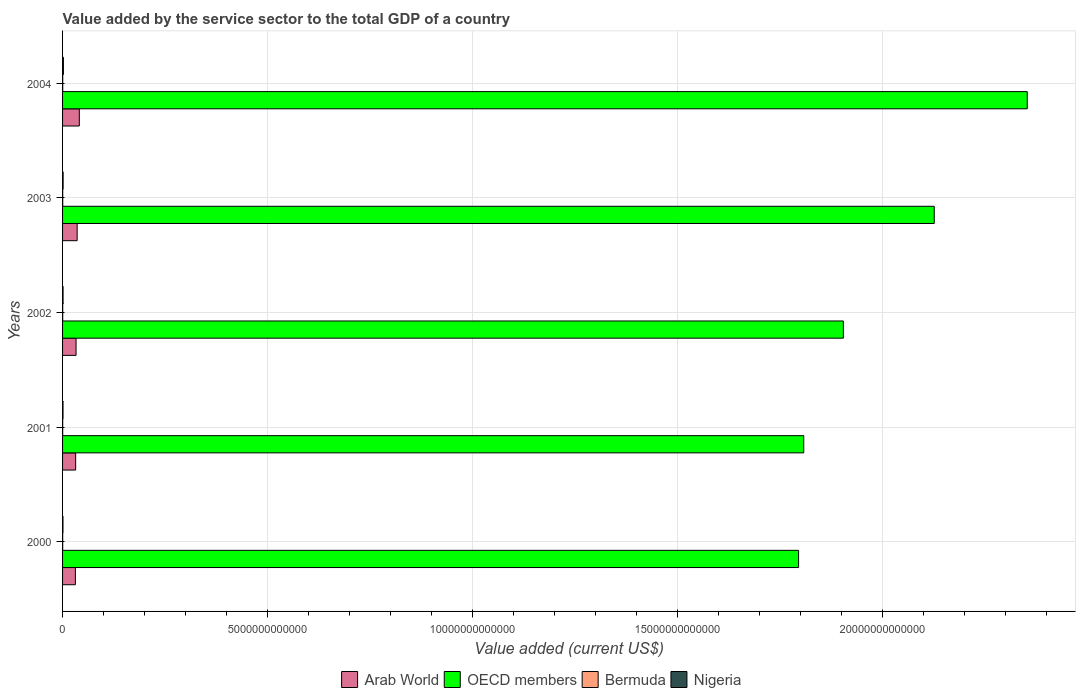How many bars are there on the 2nd tick from the top?
Provide a succinct answer. 4. How many bars are there on the 4th tick from the bottom?
Give a very brief answer. 4. What is the value added by the service sector to the total GDP in Nigeria in 2002?
Your answer should be very brief. 1.20e+1. Across all years, what is the maximum value added by the service sector to the total GDP in Arab World?
Offer a very short reply. 4.08e+11. Across all years, what is the minimum value added by the service sector to the total GDP in OECD members?
Offer a terse response. 1.79e+13. In which year was the value added by the service sector to the total GDP in OECD members maximum?
Offer a very short reply. 2004. What is the total value added by the service sector to the total GDP in OECD members in the graph?
Offer a terse response. 9.98e+13. What is the difference between the value added by the service sector to the total GDP in Bermuda in 2000 and that in 2001?
Ensure brevity in your answer.  -2.03e+08. What is the difference between the value added by the service sector to the total GDP in Bermuda in 2004 and the value added by the service sector to the total GDP in Arab World in 2002?
Ensure brevity in your answer.  -3.25e+11. What is the average value added by the service sector to the total GDP in Nigeria per year?
Your answer should be very brief. 1.33e+1. In the year 2001, what is the difference between the value added by the service sector to the total GDP in Arab World and value added by the service sector to the total GDP in OECD members?
Ensure brevity in your answer.  -1.78e+13. In how many years, is the value added by the service sector to the total GDP in Arab World greater than 10000000000000 US$?
Offer a very short reply. 0. What is the ratio of the value added by the service sector to the total GDP in Arab World in 2002 to that in 2003?
Ensure brevity in your answer.  0.93. What is the difference between the highest and the second highest value added by the service sector to the total GDP in Bermuda?
Your answer should be very brief. 2.45e+08. What is the difference between the highest and the lowest value added by the service sector to the total GDP in Arab World?
Provide a short and direct response. 9.59e+1. In how many years, is the value added by the service sector to the total GDP in Arab World greater than the average value added by the service sector to the total GDP in Arab World taken over all years?
Ensure brevity in your answer.  2. Is the sum of the value added by the service sector to the total GDP in Bermuda in 2000 and 2004 greater than the maximum value added by the service sector to the total GDP in OECD members across all years?
Make the answer very short. No. What does the 2nd bar from the top in 2004 represents?
Make the answer very short. Bermuda. Is it the case that in every year, the sum of the value added by the service sector to the total GDP in Nigeria and value added by the service sector to the total GDP in Arab World is greater than the value added by the service sector to the total GDP in Bermuda?
Offer a very short reply. Yes. Are all the bars in the graph horizontal?
Ensure brevity in your answer.  Yes. What is the difference between two consecutive major ticks on the X-axis?
Your answer should be compact. 5.00e+12. Does the graph contain any zero values?
Offer a very short reply. No. How many legend labels are there?
Keep it short and to the point. 4. What is the title of the graph?
Provide a short and direct response. Value added by the service sector to the total GDP of a country. What is the label or title of the X-axis?
Offer a terse response. Value added (current US$). What is the label or title of the Y-axis?
Your response must be concise. Years. What is the Value added (current US$) in Arab World in 2000?
Your answer should be very brief. 3.13e+11. What is the Value added (current US$) of OECD members in 2000?
Provide a short and direct response. 1.79e+13. What is the Value added (current US$) of Bermuda in 2000?
Keep it short and to the point. 2.89e+09. What is the Value added (current US$) of Nigeria in 2000?
Keep it short and to the point. 9.80e+09. What is the Value added (current US$) in Arab World in 2001?
Offer a very short reply. 3.19e+11. What is the Value added (current US$) of OECD members in 2001?
Provide a short and direct response. 1.81e+13. What is the Value added (current US$) in Bermuda in 2001?
Your response must be concise. 3.09e+09. What is the Value added (current US$) in Nigeria in 2001?
Your answer should be compact. 1.08e+1. What is the Value added (current US$) of Arab World in 2002?
Your response must be concise. 3.29e+11. What is the Value added (current US$) of OECD members in 2002?
Make the answer very short. 1.90e+13. What is the Value added (current US$) of Bermuda in 2002?
Provide a short and direct response. 3.34e+09. What is the Value added (current US$) of Nigeria in 2002?
Ensure brevity in your answer.  1.20e+1. What is the Value added (current US$) in Arab World in 2003?
Offer a very short reply. 3.56e+11. What is the Value added (current US$) of OECD members in 2003?
Provide a succinct answer. 2.13e+13. What is the Value added (current US$) of Bermuda in 2003?
Keep it short and to the point. 3.55e+09. What is the Value added (current US$) in Nigeria in 2003?
Keep it short and to the point. 1.35e+1. What is the Value added (current US$) in Arab World in 2004?
Your answer should be compact. 4.08e+11. What is the Value added (current US$) of OECD members in 2004?
Provide a short and direct response. 2.35e+13. What is the Value added (current US$) of Bermuda in 2004?
Provide a short and direct response. 3.80e+09. What is the Value added (current US$) in Nigeria in 2004?
Your answer should be compact. 2.04e+1. Across all years, what is the maximum Value added (current US$) in Arab World?
Provide a succinct answer. 4.08e+11. Across all years, what is the maximum Value added (current US$) of OECD members?
Keep it short and to the point. 2.35e+13. Across all years, what is the maximum Value added (current US$) in Bermuda?
Give a very brief answer. 3.80e+09. Across all years, what is the maximum Value added (current US$) in Nigeria?
Your answer should be very brief. 2.04e+1. Across all years, what is the minimum Value added (current US$) in Arab World?
Offer a terse response. 3.13e+11. Across all years, what is the minimum Value added (current US$) in OECD members?
Your answer should be compact. 1.79e+13. Across all years, what is the minimum Value added (current US$) in Bermuda?
Give a very brief answer. 2.89e+09. Across all years, what is the minimum Value added (current US$) of Nigeria?
Ensure brevity in your answer.  9.80e+09. What is the total Value added (current US$) in Arab World in the graph?
Your answer should be very brief. 1.72e+12. What is the total Value added (current US$) in OECD members in the graph?
Your answer should be compact. 9.98e+13. What is the total Value added (current US$) in Bermuda in the graph?
Offer a very short reply. 1.67e+1. What is the total Value added (current US$) of Nigeria in the graph?
Make the answer very short. 6.64e+1. What is the difference between the Value added (current US$) of Arab World in 2000 and that in 2001?
Give a very brief answer. -6.45e+09. What is the difference between the Value added (current US$) in OECD members in 2000 and that in 2001?
Your answer should be compact. -1.26e+11. What is the difference between the Value added (current US$) in Bermuda in 2000 and that in 2001?
Offer a very short reply. -2.03e+08. What is the difference between the Value added (current US$) in Nigeria in 2000 and that in 2001?
Offer a terse response. -9.74e+08. What is the difference between the Value added (current US$) of Arab World in 2000 and that in 2002?
Offer a terse response. -1.66e+1. What is the difference between the Value added (current US$) in OECD members in 2000 and that in 2002?
Your answer should be compact. -1.09e+12. What is the difference between the Value added (current US$) in Bermuda in 2000 and that in 2002?
Provide a succinct answer. -4.53e+08. What is the difference between the Value added (current US$) in Nigeria in 2000 and that in 2002?
Your answer should be compact. -2.19e+09. What is the difference between the Value added (current US$) in Arab World in 2000 and that in 2003?
Your response must be concise. -4.30e+1. What is the difference between the Value added (current US$) of OECD members in 2000 and that in 2003?
Offer a terse response. -3.31e+12. What is the difference between the Value added (current US$) of Bermuda in 2000 and that in 2003?
Your response must be concise. -6.67e+08. What is the difference between the Value added (current US$) of Nigeria in 2000 and that in 2003?
Ensure brevity in your answer.  -3.69e+09. What is the difference between the Value added (current US$) in Arab World in 2000 and that in 2004?
Offer a very short reply. -9.59e+1. What is the difference between the Value added (current US$) of OECD members in 2000 and that in 2004?
Your answer should be compact. -5.58e+12. What is the difference between the Value added (current US$) of Bermuda in 2000 and that in 2004?
Offer a very short reply. -9.12e+08. What is the difference between the Value added (current US$) of Nigeria in 2000 and that in 2004?
Provide a short and direct response. -1.05e+1. What is the difference between the Value added (current US$) in Arab World in 2001 and that in 2002?
Your answer should be very brief. -1.02e+1. What is the difference between the Value added (current US$) in OECD members in 2001 and that in 2002?
Your response must be concise. -9.65e+11. What is the difference between the Value added (current US$) of Bermuda in 2001 and that in 2002?
Offer a terse response. -2.49e+08. What is the difference between the Value added (current US$) in Nigeria in 2001 and that in 2002?
Give a very brief answer. -1.21e+09. What is the difference between the Value added (current US$) in Arab World in 2001 and that in 2003?
Your response must be concise. -3.66e+1. What is the difference between the Value added (current US$) in OECD members in 2001 and that in 2003?
Offer a very short reply. -3.18e+12. What is the difference between the Value added (current US$) in Bermuda in 2001 and that in 2003?
Ensure brevity in your answer.  -4.64e+08. What is the difference between the Value added (current US$) in Nigeria in 2001 and that in 2003?
Ensure brevity in your answer.  -2.71e+09. What is the difference between the Value added (current US$) of Arab World in 2001 and that in 2004?
Your response must be concise. -8.95e+1. What is the difference between the Value added (current US$) in OECD members in 2001 and that in 2004?
Offer a very short reply. -5.45e+12. What is the difference between the Value added (current US$) of Bermuda in 2001 and that in 2004?
Give a very brief answer. -7.08e+08. What is the difference between the Value added (current US$) in Nigeria in 2001 and that in 2004?
Provide a succinct answer. -9.57e+09. What is the difference between the Value added (current US$) of Arab World in 2002 and that in 2003?
Your response must be concise. -2.64e+1. What is the difference between the Value added (current US$) in OECD members in 2002 and that in 2003?
Provide a succinct answer. -2.22e+12. What is the difference between the Value added (current US$) in Bermuda in 2002 and that in 2003?
Your answer should be compact. -2.14e+08. What is the difference between the Value added (current US$) in Nigeria in 2002 and that in 2003?
Provide a succinct answer. -1.50e+09. What is the difference between the Value added (current US$) in Arab World in 2002 and that in 2004?
Provide a succinct answer. -7.93e+1. What is the difference between the Value added (current US$) in OECD members in 2002 and that in 2004?
Keep it short and to the point. -4.48e+12. What is the difference between the Value added (current US$) in Bermuda in 2002 and that in 2004?
Your answer should be very brief. -4.59e+08. What is the difference between the Value added (current US$) in Nigeria in 2002 and that in 2004?
Provide a short and direct response. -8.36e+09. What is the difference between the Value added (current US$) in Arab World in 2003 and that in 2004?
Offer a terse response. -5.29e+1. What is the difference between the Value added (current US$) in OECD members in 2003 and that in 2004?
Provide a succinct answer. -2.27e+12. What is the difference between the Value added (current US$) of Bermuda in 2003 and that in 2004?
Your response must be concise. -2.45e+08. What is the difference between the Value added (current US$) in Nigeria in 2003 and that in 2004?
Make the answer very short. -6.86e+09. What is the difference between the Value added (current US$) in Arab World in 2000 and the Value added (current US$) in OECD members in 2001?
Your response must be concise. -1.78e+13. What is the difference between the Value added (current US$) in Arab World in 2000 and the Value added (current US$) in Bermuda in 2001?
Offer a terse response. 3.09e+11. What is the difference between the Value added (current US$) of Arab World in 2000 and the Value added (current US$) of Nigeria in 2001?
Give a very brief answer. 3.02e+11. What is the difference between the Value added (current US$) of OECD members in 2000 and the Value added (current US$) of Bermuda in 2001?
Provide a short and direct response. 1.79e+13. What is the difference between the Value added (current US$) of OECD members in 2000 and the Value added (current US$) of Nigeria in 2001?
Provide a succinct answer. 1.79e+13. What is the difference between the Value added (current US$) of Bermuda in 2000 and the Value added (current US$) of Nigeria in 2001?
Give a very brief answer. -7.89e+09. What is the difference between the Value added (current US$) of Arab World in 2000 and the Value added (current US$) of OECD members in 2002?
Your answer should be compact. -1.87e+13. What is the difference between the Value added (current US$) in Arab World in 2000 and the Value added (current US$) in Bermuda in 2002?
Your response must be concise. 3.09e+11. What is the difference between the Value added (current US$) of Arab World in 2000 and the Value added (current US$) of Nigeria in 2002?
Give a very brief answer. 3.01e+11. What is the difference between the Value added (current US$) of OECD members in 2000 and the Value added (current US$) of Bermuda in 2002?
Your answer should be compact. 1.79e+13. What is the difference between the Value added (current US$) in OECD members in 2000 and the Value added (current US$) in Nigeria in 2002?
Ensure brevity in your answer.  1.79e+13. What is the difference between the Value added (current US$) in Bermuda in 2000 and the Value added (current US$) in Nigeria in 2002?
Your answer should be very brief. -9.10e+09. What is the difference between the Value added (current US$) of Arab World in 2000 and the Value added (current US$) of OECD members in 2003?
Your answer should be compact. -2.09e+13. What is the difference between the Value added (current US$) in Arab World in 2000 and the Value added (current US$) in Bermuda in 2003?
Give a very brief answer. 3.09e+11. What is the difference between the Value added (current US$) in Arab World in 2000 and the Value added (current US$) in Nigeria in 2003?
Offer a terse response. 2.99e+11. What is the difference between the Value added (current US$) in OECD members in 2000 and the Value added (current US$) in Bermuda in 2003?
Ensure brevity in your answer.  1.79e+13. What is the difference between the Value added (current US$) in OECD members in 2000 and the Value added (current US$) in Nigeria in 2003?
Keep it short and to the point. 1.79e+13. What is the difference between the Value added (current US$) of Bermuda in 2000 and the Value added (current US$) of Nigeria in 2003?
Your answer should be very brief. -1.06e+1. What is the difference between the Value added (current US$) of Arab World in 2000 and the Value added (current US$) of OECD members in 2004?
Offer a very short reply. -2.32e+13. What is the difference between the Value added (current US$) of Arab World in 2000 and the Value added (current US$) of Bermuda in 2004?
Keep it short and to the point. 3.09e+11. What is the difference between the Value added (current US$) of Arab World in 2000 and the Value added (current US$) of Nigeria in 2004?
Your answer should be compact. 2.92e+11. What is the difference between the Value added (current US$) in OECD members in 2000 and the Value added (current US$) in Bermuda in 2004?
Give a very brief answer. 1.79e+13. What is the difference between the Value added (current US$) of OECD members in 2000 and the Value added (current US$) of Nigeria in 2004?
Provide a succinct answer. 1.79e+13. What is the difference between the Value added (current US$) of Bermuda in 2000 and the Value added (current US$) of Nigeria in 2004?
Make the answer very short. -1.75e+1. What is the difference between the Value added (current US$) of Arab World in 2001 and the Value added (current US$) of OECD members in 2002?
Your answer should be very brief. -1.87e+13. What is the difference between the Value added (current US$) in Arab World in 2001 and the Value added (current US$) in Bermuda in 2002?
Offer a terse response. 3.16e+11. What is the difference between the Value added (current US$) of Arab World in 2001 and the Value added (current US$) of Nigeria in 2002?
Keep it short and to the point. 3.07e+11. What is the difference between the Value added (current US$) in OECD members in 2001 and the Value added (current US$) in Bermuda in 2002?
Provide a short and direct response. 1.81e+13. What is the difference between the Value added (current US$) of OECD members in 2001 and the Value added (current US$) of Nigeria in 2002?
Make the answer very short. 1.81e+13. What is the difference between the Value added (current US$) in Bermuda in 2001 and the Value added (current US$) in Nigeria in 2002?
Provide a succinct answer. -8.90e+09. What is the difference between the Value added (current US$) in Arab World in 2001 and the Value added (current US$) in OECD members in 2003?
Offer a very short reply. -2.09e+13. What is the difference between the Value added (current US$) in Arab World in 2001 and the Value added (current US$) in Bermuda in 2003?
Provide a short and direct response. 3.15e+11. What is the difference between the Value added (current US$) in Arab World in 2001 and the Value added (current US$) in Nigeria in 2003?
Offer a terse response. 3.05e+11. What is the difference between the Value added (current US$) in OECD members in 2001 and the Value added (current US$) in Bermuda in 2003?
Keep it short and to the point. 1.81e+13. What is the difference between the Value added (current US$) of OECD members in 2001 and the Value added (current US$) of Nigeria in 2003?
Your answer should be very brief. 1.81e+13. What is the difference between the Value added (current US$) in Bermuda in 2001 and the Value added (current US$) in Nigeria in 2003?
Keep it short and to the point. -1.04e+1. What is the difference between the Value added (current US$) in Arab World in 2001 and the Value added (current US$) in OECD members in 2004?
Your answer should be compact. -2.32e+13. What is the difference between the Value added (current US$) in Arab World in 2001 and the Value added (current US$) in Bermuda in 2004?
Your answer should be very brief. 3.15e+11. What is the difference between the Value added (current US$) in Arab World in 2001 and the Value added (current US$) in Nigeria in 2004?
Provide a short and direct response. 2.99e+11. What is the difference between the Value added (current US$) of OECD members in 2001 and the Value added (current US$) of Bermuda in 2004?
Make the answer very short. 1.81e+13. What is the difference between the Value added (current US$) of OECD members in 2001 and the Value added (current US$) of Nigeria in 2004?
Provide a short and direct response. 1.80e+13. What is the difference between the Value added (current US$) of Bermuda in 2001 and the Value added (current US$) of Nigeria in 2004?
Ensure brevity in your answer.  -1.73e+1. What is the difference between the Value added (current US$) of Arab World in 2002 and the Value added (current US$) of OECD members in 2003?
Ensure brevity in your answer.  -2.09e+13. What is the difference between the Value added (current US$) of Arab World in 2002 and the Value added (current US$) of Bermuda in 2003?
Give a very brief answer. 3.26e+11. What is the difference between the Value added (current US$) in Arab World in 2002 and the Value added (current US$) in Nigeria in 2003?
Your answer should be very brief. 3.16e+11. What is the difference between the Value added (current US$) of OECD members in 2002 and the Value added (current US$) of Bermuda in 2003?
Your answer should be compact. 1.90e+13. What is the difference between the Value added (current US$) of OECD members in 2002 and the Value added (current US$) of Nigeria in 2003?
Keep it short and to the point. 1.90e+13. What is the difference between the Value added (current US$) of Bermuda in 2002 and the Value added (current US$) of Nigeria in 2003?
Make the answer very short. -1.02e+1. What is the difference between the Value added (current US$) in Arab World in 2002 and the Value added (current US$) in OECD members in 2004?
Provide a succinct answer. -2.32e+13. What is the difference between the Value added (current US$) in Arab World in 2002 and the Value added (current US$) in Bermuda in 2004?
Offer a very short reply. 3.25e+11. What is the difference between the Value added (current US$) in Arab World in 2002 and the Value added (current US$) in Nigeria in 2004?
Provide a succinct answer. 3.09e+11. What is the difference between the Value added (current US$) of OECD members in 2002 and the Value added (current US$) of Bermuda in 2004?
Provide a short and direct response. 1.90e+13. What is the difference between the Value added (current US$) of OECD members in 2002 and the Value added (current US$) of Nigeria in 2004?
Ensure brevity in your answer.  1.90e+13. What is the difference between the Value added (current US$) in Bermuda in 2002 and the Value added (current US$) in Nigeria in 2004?
Provide a short and direct response. -1.70e+1. What is the difference between the Value added (current US$) of Arab World in 2003 and the Value added (current US$) of OECD members in 2004?
Your response must be concise. -2.32e+13. What is the difference between the Value added (current US$) of Arab World in 2003 and the Value added (current US$) of Bermuda in 2004?
Your answer should be compact. 3.52e+11. What is the difference between the Value added (current US$) of Arab World in 2003 and the Value added (current US$) of Nigeria in 2004?
Make the answer very short. 3.35e+11. What is the difference between the Value added (current US$) in OECD members in 2003 and the Value added (current US$) in Bermuda in 2004?
Your response must be concise. 2.12e+13. What is the difference between the Value added (current US$) of OECD members in 2003 and the Value added (current US$) of Nigeria in 2004?
Ensure brevity in your answer.  2.12e+13. What is the difference between the Value added (current US$) of Bermuda in 2003 and the Value added (current US$) of Nigeria in 2004?
Make the answer very short. -1.68e+1. What is the average Value added (current US$) of Arab World per year?
Your response must be concise. 3.45e+11. What is the average Value added (current US$) in OECD members per year?
Your answer should be very brief. 2.00e+13. What is the average Value added (current US$) in Bermuda per year?
Provide a short and direct response. 3.33e+09. What is the average Value added (current US$) of Nigeria per year?
Make the answer very short. 1.33e+1. In the year 2000, what is the difference between the Value added (current US$) in Arab World and Value added (current US$) in OECD members?
Your answer should be very brief. -1.76e+13. In the year 2000, what is the difference between the Value added (current US$) in Arab World and Value added (current US$) in Bermuda?
Offer a very short reply. 3.10e+11. In the year 2000, what is the difference between the Value added (current US$) in Arab World and Value added (current US$) in Nigeria?
Keep it short and to the point. 3.03e+11. In the year 2000, what is the difference between the Value added (current US$) in OECD members and Value added (current US$) in Bermuda?
Provide a short and direct response. 1.79e+13. In the year 2000, what is the difference between the Value added (current US$) of OECD members and Value added (current US$) of Nigeria?
Provide a succinct answer. 1.79e+13. In the year 2000, what is the difference between the Value added (current US$) of Bermuda and Value added (current US$) of Nigeria?
Your answer should be compact. -6.92e+09. In the year 2001, what is the difference between the Value added (current US$) in Arab World and Value added (current US$) in OECD members?
Your response must be concise. -1.78e+13. In the year 2001, what is the difference between the Value added (current US$) of Arab World and Value added (current US$) of Bermuda?
Ensure brevity in your answer.  3.16e+11. In the year 2001, what is the difference between the Value added (current US$) in Arab World and Value added (current US$) in Nigeria?
Keep it short and to the point. 3.08e+11. In the year 2001, what is the difference between the Value added (current US$) in OECD members and Value added (current US$) in Bermuda?
Your response must be concise. 1.81e+13. In the year 2001, what is the difference between the Value added (current US$) of OECD members and Value added (current US$) of Nigeria?
Your answer should be compact. 1.81e+13. In the year 2001, what is the difference between the Value added (current US$) in Bermuda and Value added (current US$) in Nigeria?
Make the answer very short. -7.69e+09. In the year 2002, what is the difference between the Value added (current US$) in Arab World and Value added (current US$) in OECD members?
Provide a succinct answer. -1.87e+13. In the year 2002, what is the difference between the Value added (current US$) in Arab World and Value added (current US$) in Bermuda?
Keep it short and to the point. 3.26e+11. In the year 2002, what is the difference between the Value added (current US$) in Arab World and Value added (current US$) in Nigeria?
Make the answer very short. 3.17e+11. In the year 2002, what is the difference between the Value added (current US$) of OECD members and Value added (current US$) of Bermuda?
Give a very brief answer. 1.90e+13. In the year 2002, what is the difference between the Value added (current US$) of OECD members and Value added (current US$) of Nigeria?
Your response must be concise. 1.90e+13. In the year 2002, what is the difference between the Value added (current US$) of Bermuda and Value added (current US$) of Nigeria?
Give a very brief answer. -8.65e+09. In the year 2003, what is the difference between the Value added (current US$) of Arab World and Value added (current US$) of OECD members?
Your answer should be compact. -2.09e+13. In the year 2003, what is the difference between the Value added (current US$) of Arab World and Value added (current US$) of Bermuda?
Provide a short and direct response. 3.52e+11. In the year 2003, what is the difference between the Value added (current US$) in Arab World and Value added (current US$) in Nigeria?
Give a very brief answer. 3.42e+11. In the year 2003, what is the difference between the Value added (current US$) of OECD members and Value added (current US$) of Bermuda?
Keep it short and to the point. 2.12e+13. In the year 2003, what is the difference between the Value added (current US$) of OECD members and Value added (current US$) of Nigeria?
Ensure brevity in your answer.  2.12e+13. In the year 2003, what is the difference between the Value added (current US$) in Bermuda and Value added (current US$) in Nigeria?
Provide a succinct answer. -9.94e+09. In the year 2004, what is the difference between the Value added (current US$) of Arab World and Value added (current US$) of OECD members?
Your answer should be compact. -2.31e+13. In the year 2004, what is the difference between the Value added (current US$) in Arab World and Value added (current US$) in Bermuda?
Your response must be concise. 4.05e+11. In the year 2004, what is the difference between the Value added (current US$) of Arab World and Value added (current US$) of Nigeria?
Keep it short and to the point. 3.88e+11. In the year 2004, what is the difference between the Value added (current US$) in OECD members and Value added (current US$) in Bermuda?
Your answer should be very brief. 2.35e+13. In the year 2004, what is the difference between the Value added (current US$) in OECD members and Value added (current US$) in Nigeria?
Your answer should be very brief. 2.35e+13. In the year 2004, what is the difference between the Value added (current US$) of Bermuda and Value added (current US$) of Nigeria?
Your answer should be very brief. -1.66e+1. What is the ratio of the Value added (current US$) of Arab World in 2000 to that in 2001?
Ensure brevity in your answer.  0.98. What is the ratio of the Value added (current US$) in OECD members in 2000 to that in 2001?
Offer a terse response. 0.99. What is the ratio of the Value added (current US$) in Bermuda in 2000 to that in 2001?
Your response must be concise. 0.93. What is the ratio of the Value added (current US$) in Nigeria in 2000 to that in 2001?
Offer a very short reply. 0.91. What is the ratio of the Value added (current US$) in Arab World in 2000 to that in 2002?
Your answer should be compact. 0.95. What is the ratio of the Value added (current US$) in OECD members in 2000 to that in 2002?
Provide a succinct answer. 0.94. What is the ratio of the Value added (current US$) of Bermuda in 2000 to that in 2002?
Offer a very short reply. 0.86. What is the ratio of the Value added (current US$) of Nigeria in 2000 to that in 2002?
Ensure brevity in your answer.  0.82. What is the ratio of the Value added (current US$) of Arab World in 2000 to that in 2003?
Provide a short and direct response. 0.88. What is the ratio of the Value added (current US$) of OECD members in 2000 to that in 2003?
Give a very brief answer. 0.84. What is the ratio of the Value added (current US$) in Bermuda in 2000 to that in 2003?
Ensure brevity in your answer.  0.81. What is the ratio of the Value added (current US$) of Nigeria in 2000 to that in 2003?
Keep it short and to the point. 0.73. What is the ratio of the Value added (current US$) of Arab World in 2000 to that in 2004?
Provide a short and direct response. 0.77. What is the ratio of the Value added (current US$) of OECD members in 2000 to that in 2004?
Offer a very short reply. 0.76. What is the ratio of the Value added (current US$) in Bermuda in 2000 to that in 2004?
Give a very brief answer. 0.76. What is the ratio of the Value added (current US$) in Nigeria in 2000 to that in 2004?
Offer a very short reply. 0.48. What is the ratio of the Value added (current US$) of Arab World in 2001 to that in 2002?
Provide a short and direct response. 0.97. What is the ratio of the Value added (current US$) of OECD members in 2001 to that in 2002?
Your response must be concise. 0.95. What is the ratio of the Value added (current US$) of Bermuda in 2001 to that in 2002?
Offer a very short reply. 0.93. What is the ratio of the Value added (current US$) of Nigeria in 2001 to that in 2002?
Provide a succinct answer. 0.9. What is the ratio of the Value added (current US$) in Arab World in 2001 to that in 2003?
Offer a terse response. 0.9. What is the ratio of the Value added (current US$) in OECD members in 2001 to that in 2003?
Your response must be concise. 0.85. What is the ratio of the Value added (current US$) in Bermuda in 2001 to that in 2003?
Your response must be concise. 0.87. What is the ratio of the Value added (current US$) of Nigeria in 2001 to that in 2003?
Ensure brevity in your answer.  0.8. What is the ratio of the Value added (current US$) of Arab World in 2001 to that in 2004?
Offer a terse response. 0.78. What is the ratio of the Value added (current US$) in OECD members in 2001 to that in 2004?
Offer a very short reply. 0.77. What is the ratio of the Value added (current US$) of Bermuda in 2001 to that in 2004?
Provide a succinct answer. 0.81. What is the ratio of the Value added (current US$) in Nigeria in 2001 to that in 2004?
Your answer should be compact. 0.53. What is the ratio of the Value added (current US$) in Arab World in 2002 to that in 2003?
Offer a terse response. 0.93. What is the ratio of the Value added (current US$) of OECD members in 2002 to that in 2003?
Provide a short and direct response. 0.9. What is the ratio of the Value added (current US$) in Bermuda in 2002 to that in 2003?
Your answer should be very brief. 0.94. What is the ratio of the Value added (current US$) of Nigeria in 2002 to that in 2003?
Provide a short and direct response. 0.89. What is the ratio of the Value added (current US$) in Arab World in 2002 to that in 2004?
Provide a succinct answer. 0.81. What is the ratio of the Value added (current US$) of OECD members in 2002 to that in 2004?
Offer a terse response. 0.81. What is the ratio of the Value added (current US$) in Bermuda in 2002 to that in 2004?
Provide a succinct answer. 0.88. What is the ratio of the Value added (current US$) in Nigeria in 2002 to that in 2004?
Offer a terse response. 0.59. What is the ratio of the Value added (current US$) of Arab World in 2003 to that in 2004?
Your answer should be compact. 0.87. What is the ratio of the Value added (current US$) in OECD members in 2003 to that in 2004?
Provide a succinct answer. 0.9. What is the ratio of the Value added (current US$) in Bermuda in 2003 to that in 2004?
Offer a terse response. 0.94. What is the ratio of the Value added (current US$) of Nigeria in 2003 to that in 2004?
Ensure brevity in your answer.  0.66. What is the difference between the highest and the second highest Value added (current US$) of Arab World?
Provide a succinct answer. 5.29e+1. What is the difference between the highest and the second highest Value added (current US$) of OECD members?
Your answer should be compact. 2.27e+12. What is the difference between the highest and the second highest Value added (current US$) in Bermuda?
Your answer should be compact. 2.45e+08. What is the difference between the highest and the second highest Value added (current US$) of Nigeria?
Ensure brevity in your answer.  6.86e+09. What is the difference between the highest and the lowest Value added (current US$) of Arab World?
Offer a terse response. 9.59e+1. What is the difference between the highest and the lowest Value added (current US$) of OECD members?
Provide a short and direct response. 5.58e+12. What is the difference between the highest and the lowest Value added (current US$) of Bermuda?
Provide a succinct answer. 9.12e+08. What is the difference between the highest and the lowest Value added (current US$) of Nigeria?
Your response must be concise. 1.05e+1. 